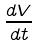<formula> <loc_0><loc_0><loc_500><loc_500>\frac { d V } { d t }</formula> 